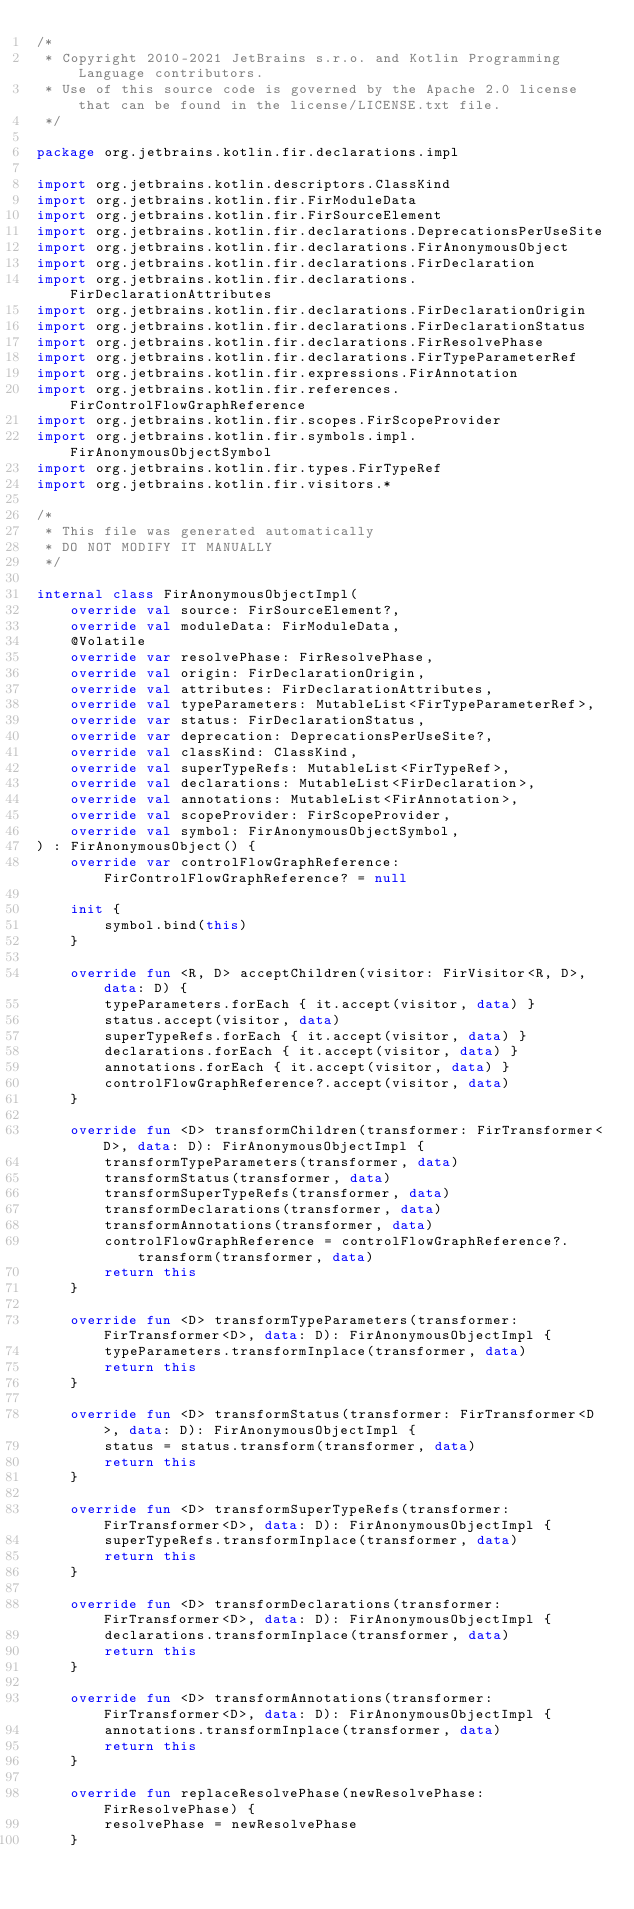<code> <loc_0><loc_0><loc_500><loc_500><_Kotlin_>/*
 * Copyright 2010-2021 JetBrains s.r.o. and Kotlin Programming Language contributors.
 * Use of this source code is governed by the Apache 2.0 license that can be found in the license/LICENSE.txt file.
 */

package org.jetbrains.kotlin.fir.declarations.impl

import org.jetbrains.kotlin.descriptors.ClassKind
import org.jetbrains.kotlin.fir.FirModuleData
import org.jetbrains.kotlin.fir.FirSourceElement
import org.jetbrains.kotlin.fir.declarations.DeprecationsPerUseSite
import org.jetbrains.kotlin.fir.declarations.FirAnonymousObject
import org.jetbrains.kotlin.fir.declarations.FirDeclaration
import org.jetbrains.kotlin.fir.declarations.FirDeclarationAttributes
import org.jetbrains.kotlin.fir.declarations.FirDeclarationOrigin
import org.jetbrains.kotlin.fir.declarations.FirDeclarationStatus
import org.jetbrains.kotlin.fir.declarations.FirResolvePhase
import org.jetbrains.kotlin.fir.declarations.FirTypeParameterRef
import org.jetbrains.kotlin.fir.expressions.FirAnnotation
import org.jetbrains.kotlin.fir.references.FirControlFlowGraphReference
import org.jetbrains.kotlin.fir.scopes.FirScopeProvider
import org.jetbrains.kotlin.fir.symbols.impl.FirAnonymousObjectSymbol
import org.jetbrains.kotlin.fir.types.FirTypeRef
import org.jetbrains.kotlin.fir.visitors.*

/*
 * This file was generated automatically
 * DO NOT MODIFY IT MANUALLY
 */

internal class FirAnonymousObjectImpl(
    override val source: FirSourceElement?,
    override val moduleData: FirModuleData,
    @Volatile
    override var resolvePhase: FirResolvePhase,
    override val origin: FirDeclarationOrigin,
    override val attributes: FirDeclarationAttributes,
    override val typeParameters: MutableList<FirTypeParameterRef>,
    override var status: FirDeclarationStatus,
    override var deprecation: DeprecationsPerUseSite?,
    override val classKind: ClassKind,
    override val superTypeRefs: MutableList<FirTypeRef>,
    override val declarations: MutableList<FirDeclaration>,
    override val annotations: MutableList<FirAnnotation>,
    override val scopeProvider: FirScopeProvider,
    override val symbol: FirAnonymousObjectSymbol,
) : FirAnonymousObject() {
    override var controlFlowGraphReference: FirControlFlowGraphReference? = null

    init {
        symbol.bind(this)
    }

    override fun <R, D> acceptChildren(visitor: FirVisitor<R, D>, data: D) {
        typeParameters.forEach { it.accept(visitor, data) }
        status.accept(visitor, data)
        superTypeRefs.forEach { it.accept(visitor, data) }
        declarations.forEach { it.accept(visitor, data) }
        annotations.forEach { it.accept(visitor, data) }
        controlFlowGraphReference?.accept(visitor, data)
    }

    override fun <D> transformChildren(transformer: FirTransformer<D>, data: D): FirAnonymousObjectImpl {
        transformTypeParameters(transformer, data)
        transformStatus(transformer, data)
        transformSuperTypeRefs(transformer, data)
        transformDeclarations(transformer, data)
        transformAnnotations(transformer, data)
        controlFlowGraphReference = controlFlowGraphReference?.transform(transformer, data)
        return this
    }

    override fun <D> transformTypeParameters(transformer: FirTransformer<D>, data: D): FirAnonymousObjectImpl {
        typeParameters.transformInplace(transformer, data)
        return this
    }

    override fun <D> transformStatus(transformer: FirTransformer<D>, data: D): FirAnonymousObjectImpl {
        status = status.transform(transformer, data)
        return this
    }

    override fun <D> transformSuperTypeRefs(transformer: FirTransformer<D>, data: D): FirAnonymousObjectImpl {
        superTypeRefs.transformInplace(transformer, data)
        return this
    }

    override fun <D> transformDeclarations(transformer: FirTransformer<D>, data: D): FirAnonymousObjectImpl {
        declarations.transformInplace(transformer, data)
        return this
    }

    override fun <D> transformAnnotations(transformer: FirTransformer<D>, data: D): FirAnonymousObjectImpl {
        annotations.transformInplace(transformer, data)
        return this
    }

    override fun replaceResolvePhase(newResolvePhase: FirResolvePhase) {
        resolvePhase = newResolvePhase
    }
</code> 